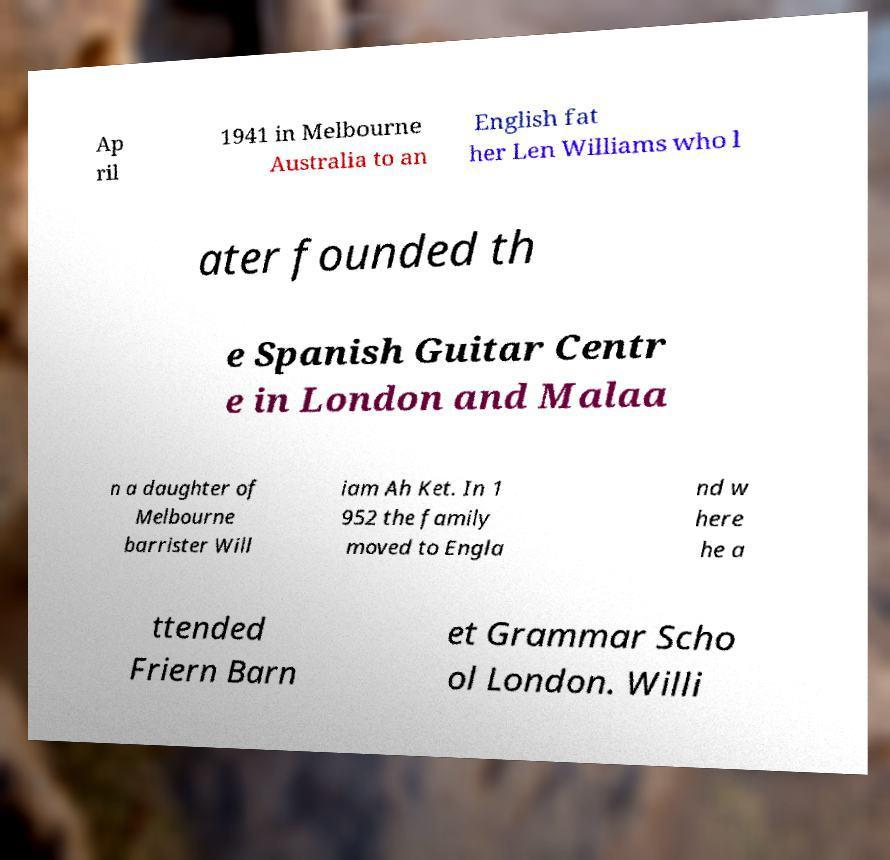Please read and relay the text visible in this image. What does it say? Ap ril 1941 in Melbourne Australia to an English fat her Len Williams who l ater founded th e Spanish Guitar Centr e in London and Malaa n a daughter of Melbourne barrister Will iam Ah Ket. In 1 952 the family moved to Engla nd w here he a ttended Friern Barn et Grammar Scho ol London. Willi 